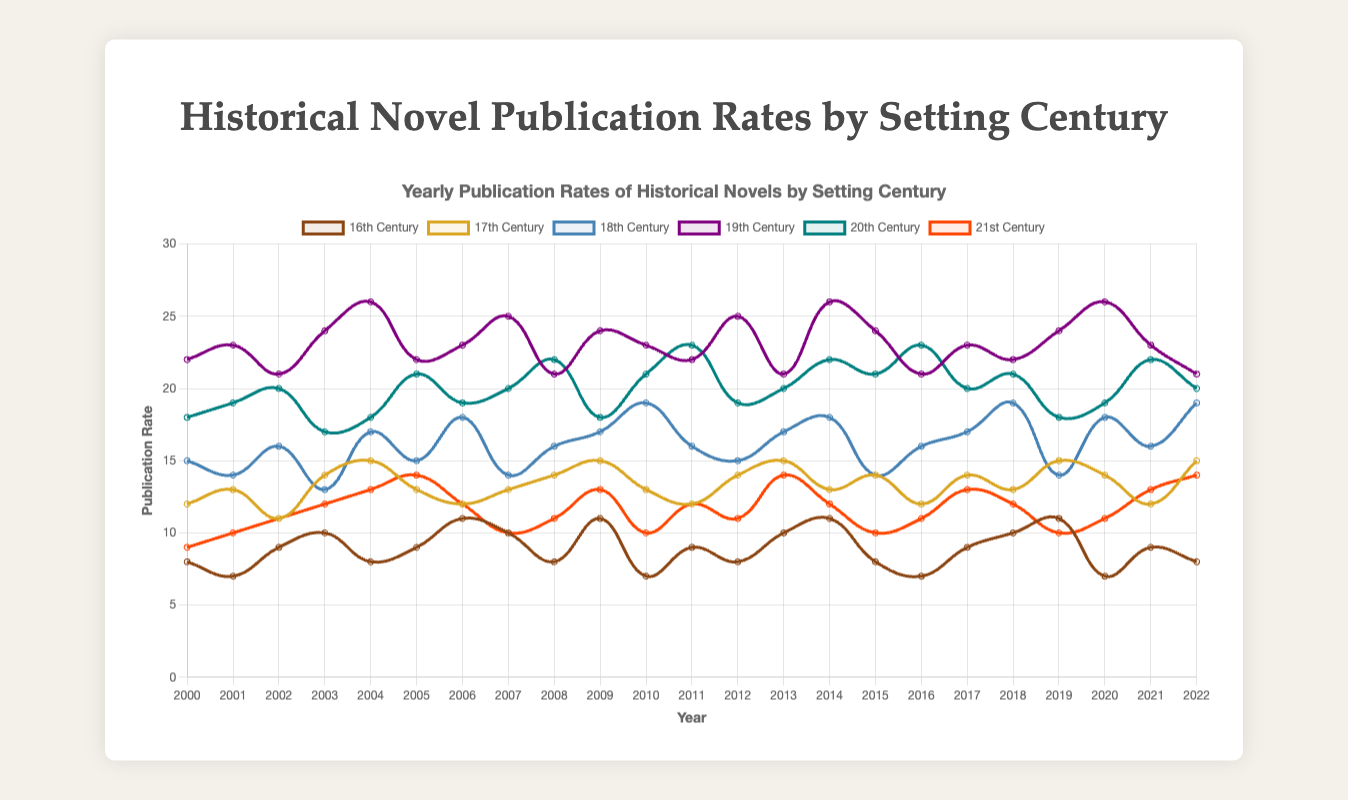What is the highest publication rate for the 19th Century, and in which year did it occur? Look at the dataset and find the maximum value for the column representing the 19th Century, which is 26 in the years 2004, 2014, and 2020.
Answer: 26 in 2004, 2014, and 2020 Comparing the 18th Century and 21st Century, which has the greater publication rate in 2022? Compare the numbers in the dataset for the year 2022: 18th Century has 19, and 21st Century has 14. The 18th Century has a higher number.
Answer: 18th Century What is the average publication rate for the 20th Century from 2000 to 2022? Add up all yearly publication rates for the 20th Century and divide by the number of years (23): (18+19+20+17+18+21+19+20+22+18+21+23+19+20+22+21+23+20+21+18+19+22+20) = 465. Then, 465 / 23.
Answer: 20.22 How does the publication rate of the 16th Century in 2006 compare to its rate in 2016? For 2006, it is 11, and for 2016, it is 7. The publication rate in 2006 is higher than in 2016.
Answer: 2006 is higher Which century had the lowest publication rate in 2008, and what was it? Look at the data for the year 2008 and find the lowest number among all centuries: 16th Century (8), 17th Century (14), 18th Century (16), 19th Century (21), 20th Century (22), 21st Century (11). The lowest is in the 16th Century with 8.
Answer: 16th Century with 8 In which year did the 20th Century have the highest publication rate, and what was the value? Check the dataset for the 20th Century column and find the highest value and the corresponding year: 23 in 2011, 2016, and 2021.
Answer: 23 in 2011, 2016, and 2021 By how much did the publication rate of the 17th Century change from 2000 to 2010? Subtract the rate in 2000 from the rate in 2010 for the 17th Century: 13 - 12 = 1.
Answer: Increased by 1 What are the visual characteristics used to differentiate the 21st Century publication rate in the chart? Observe the chart's visual presentation: the 21st Century line is represented with a red color that has an orange hue and background transparency for better visualization.
Answer: Red line with semi-transparent orange background In which year did the 18th Century see its highest publication rate, and what was the rate? Look for the highest value in the dataset for the 18th Century and the corresponding year: 19 in 2010, 2018, and 2022.
Answer: 19 in 2010, 2018, and 2022 Which centuries have the same publication rates in 2019, and what are those rates? Compare the values for each century for 2019: 16th Century (11), 17th Century (15), 18th Century (14), 19th Century (24), 20th Century (18), and 21st Century (10). The 18th and 21st Centuries have 14 and 10, respectively.
Answer: 16th Century and 20th Century with 18 